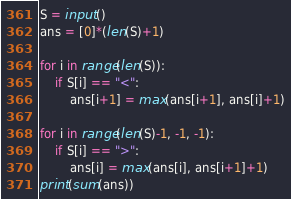<code> <loc_0><loc_0><loc_500><loc_500><_Python_>S = input()
ans = [0]*(len(S)+1)

for i in range(len(S)):
    if S[i] == "<":
        ans[i+1] = max(ans[i+1], ans[i]+1)

for i in range(len(S)-1, -1, -1):
    if S[i] == ">":
        ans[i] = max(ans[i], ans[i+1]+1)
print(sum(ans))</code> 